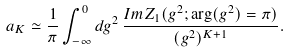<formula> <loc_0><loc_0><loc_500><loc_500>a _ { K } \simeq \frac { 1 } { \pi } \int _ { - \infty } ^ { 0 } d g ^ { 2 } \, \frac { I m Z _ { 1 } ( g ^ { 2 } ; \arg ( g ^ { 2 } ) = \pi ) } { ( g ^ { 2 } ) ^ { K + 1 } } .</formula> 